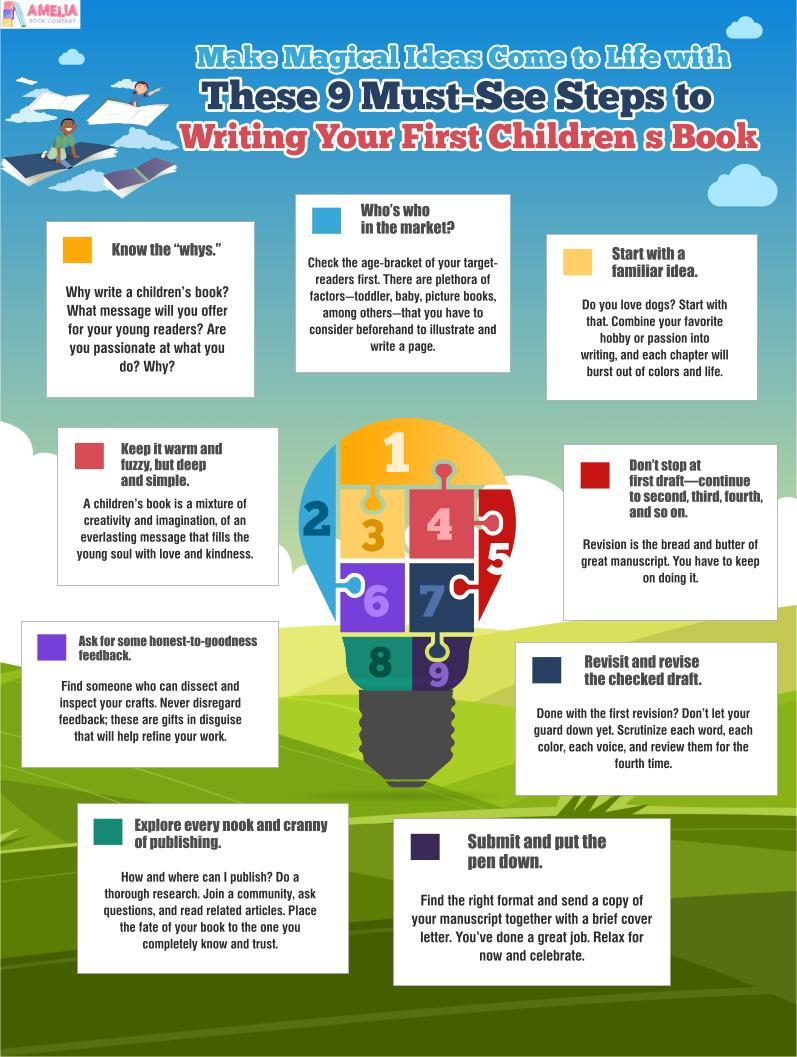Which step is represented by the blue square, Know the "whys", Who's who in the market?, or Start with an idea?
Answer the question with a short phrase. Who's who in the market? What is the color of the square that represents the step honest feedback, red, violet, or dark blue? violet 